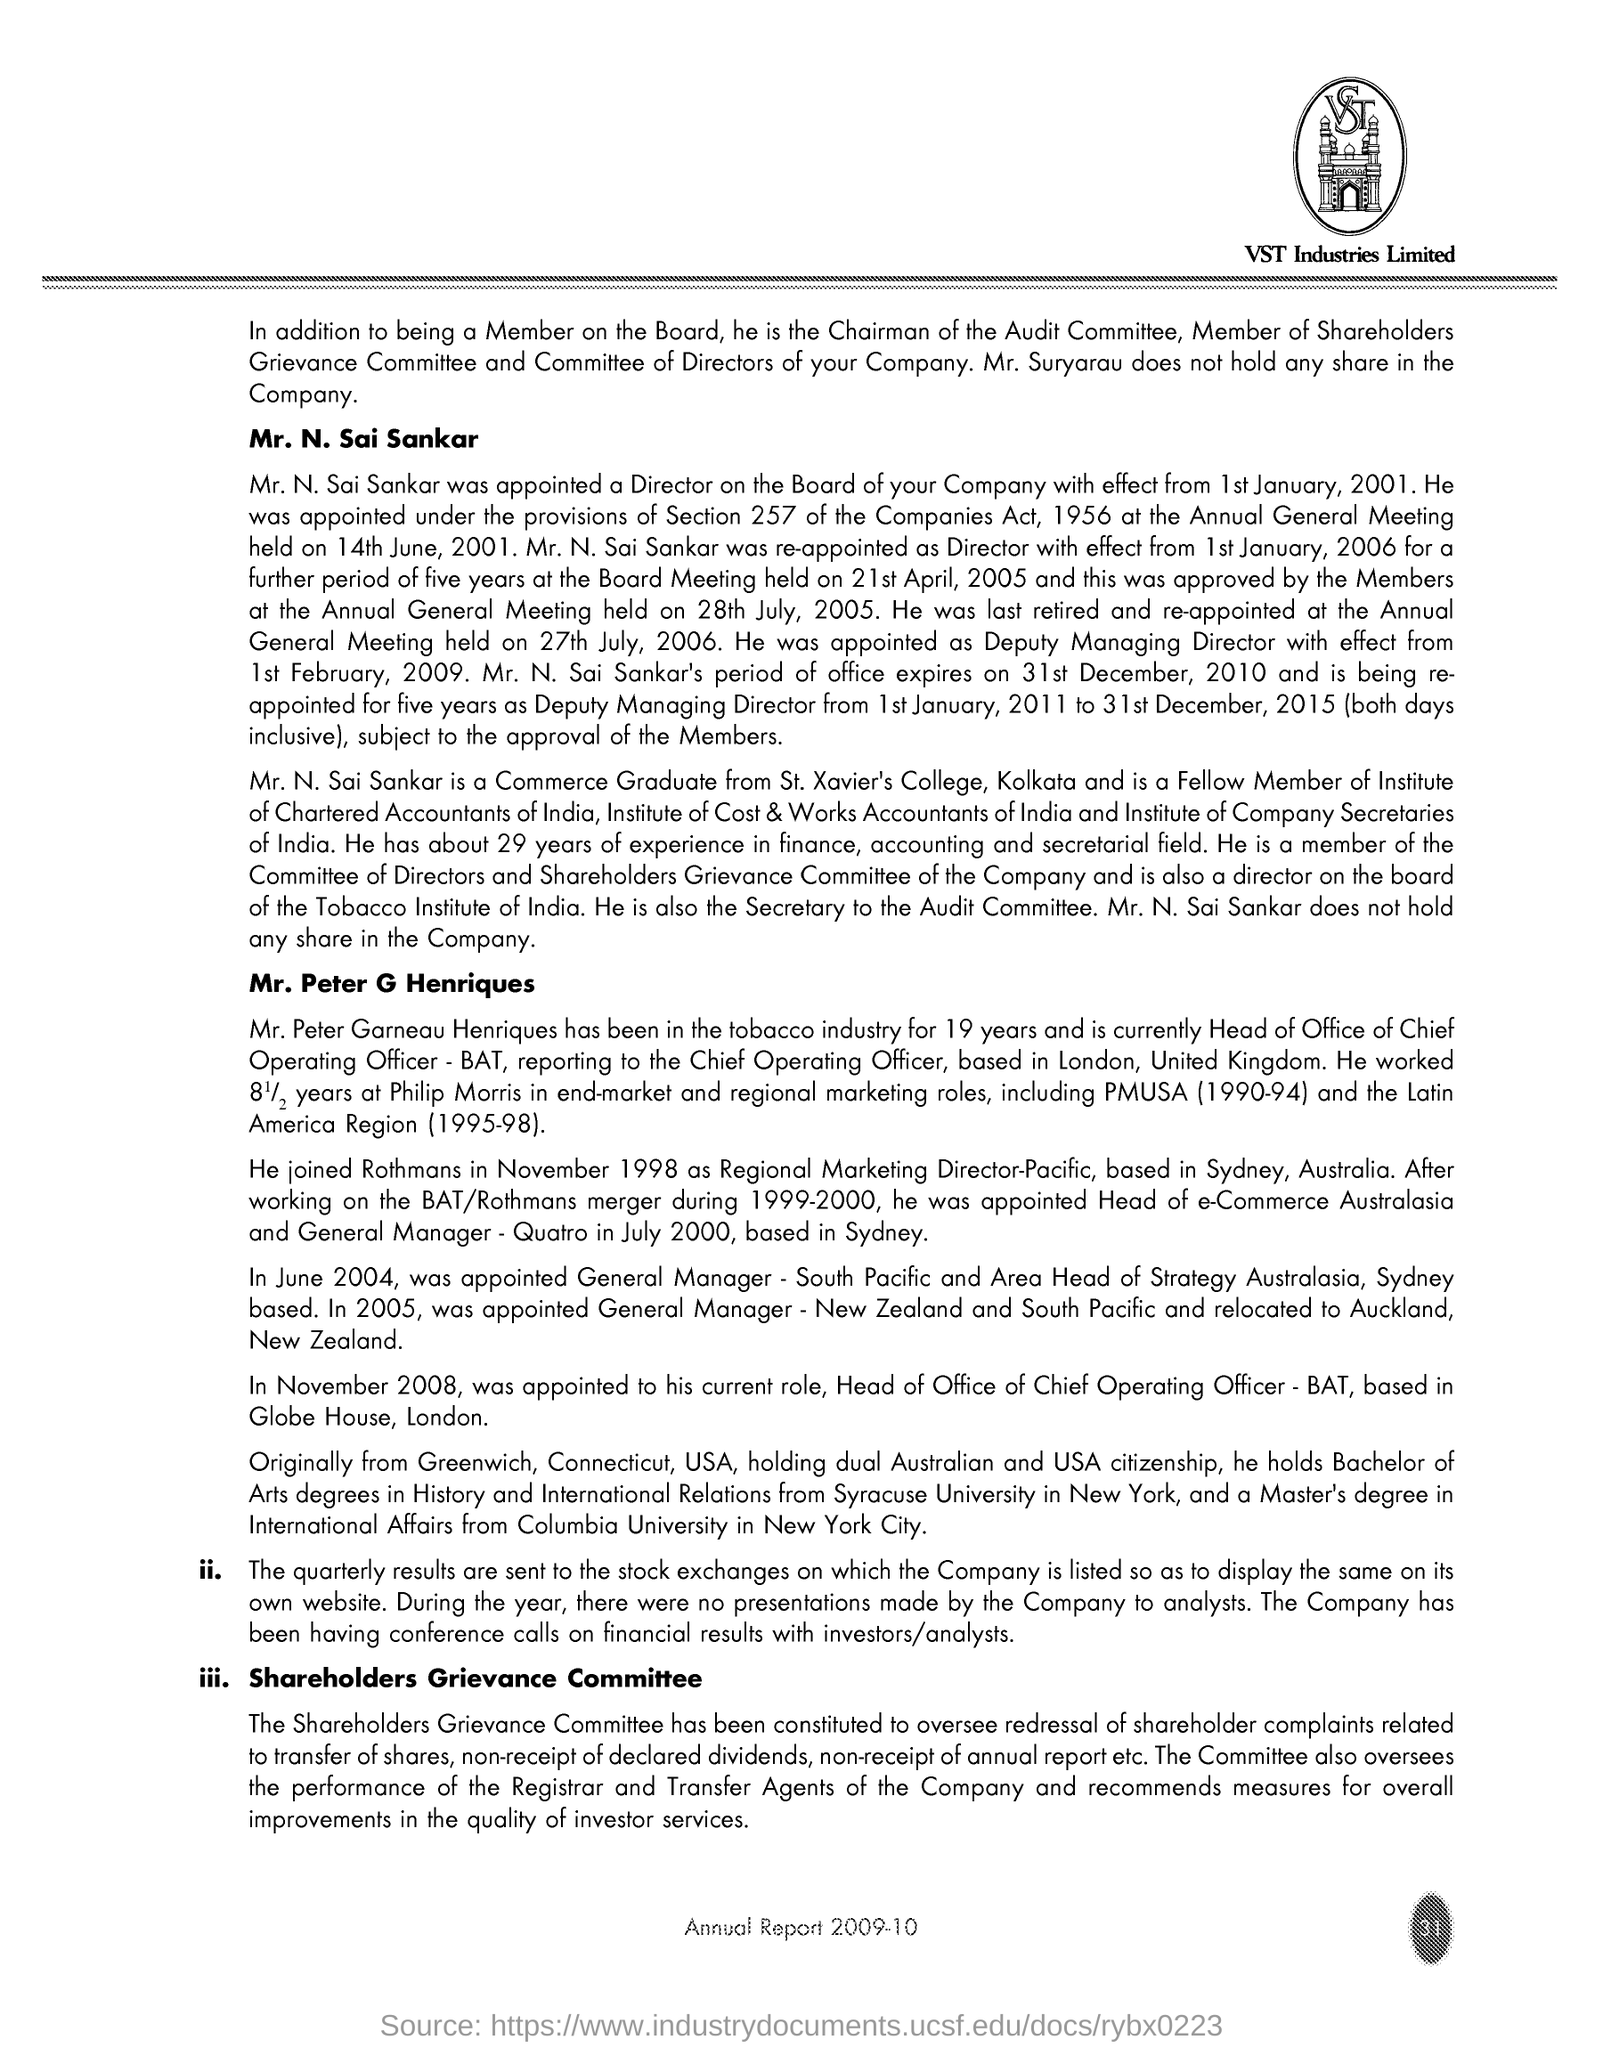Highlight a few significant elements in this photo. The text 'Which text is in the image? VST..' is present in the image. Below the image is the text 'VST Industries Limited.' Page 31 is the page number. 